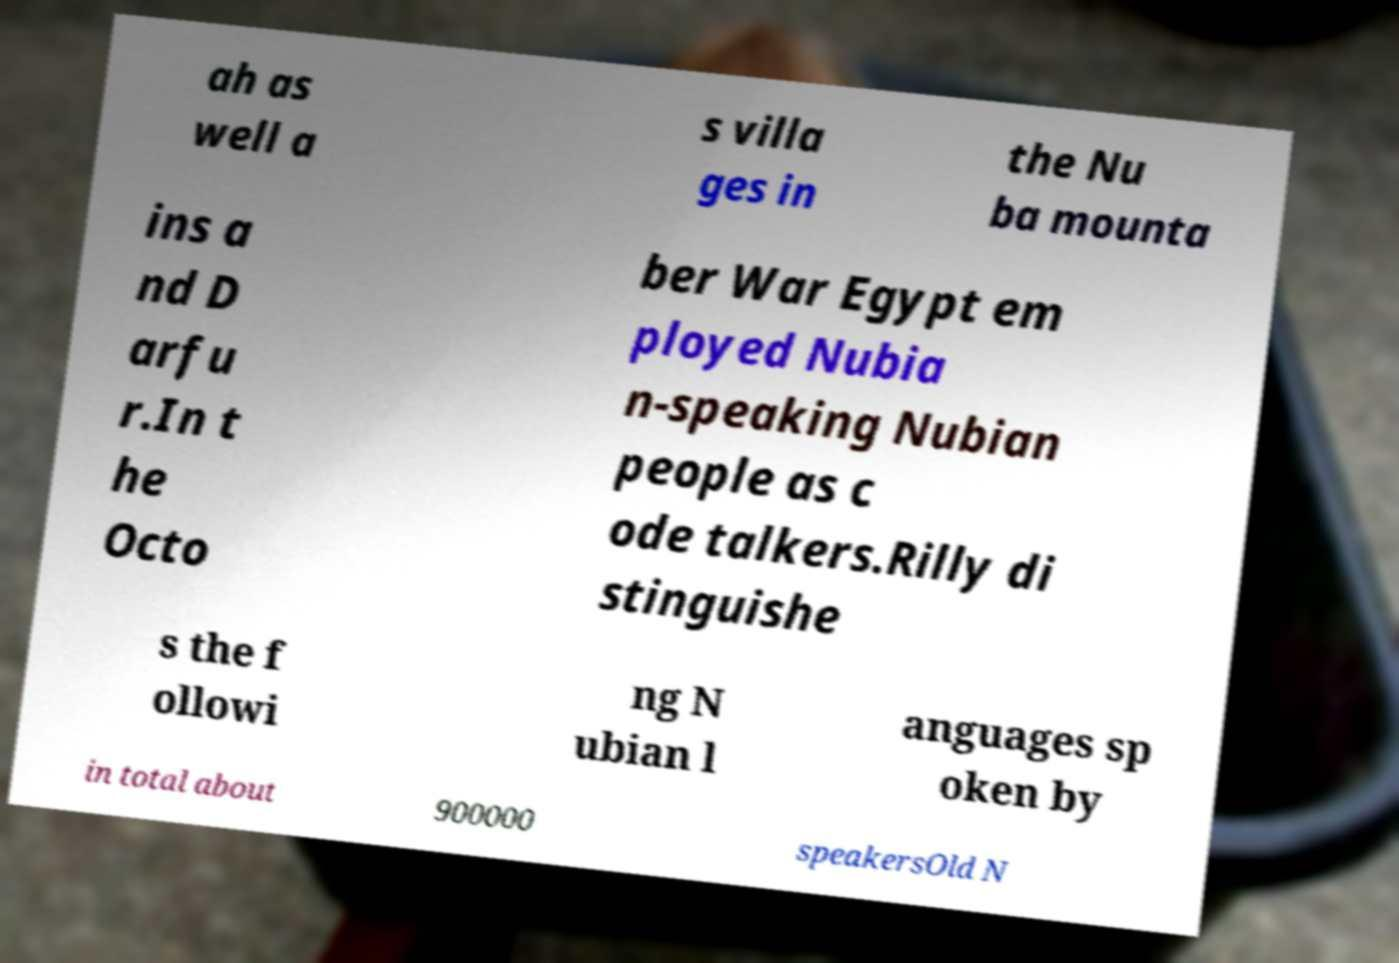For documentation purposes, I need the text within this image transcribed. Could you provide that? ah as well a s villa ges in the Nu ba mounta ins a nd D arfu r.In t he Octo ber War Egypt em ployed Nubia n-speaking Nubian people as c ode talkers.Rilly di stinguishe s the f ollowi ng N ubian l anguages sp oken by in total about 900000 speakersOld N 